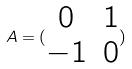<formula> <loc_0><loc_0><loc_500><loc_500>A = ( \begin{matrix} 0 & 1 \\ - 1 & 0 \end{matrix} )</formula> 